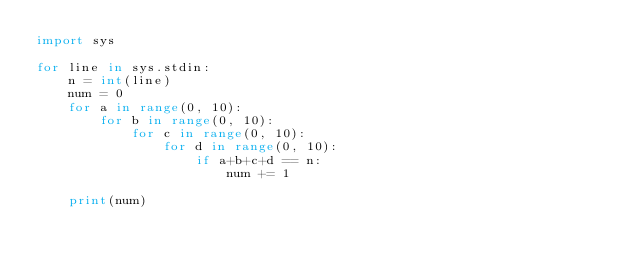<code> <loc_0><loc_0><loc_500><loc_500><_Python_>import sys

for line in sys.stdin:
    n = int(line)
    num = 0
    for a in range(0, 10):
        for b in range(0, 10):
            for c in range(0, 10):
                for d in range(0, 10):
                    if a+b+c+d == n:
                        num += 1

    print(num)</code> 